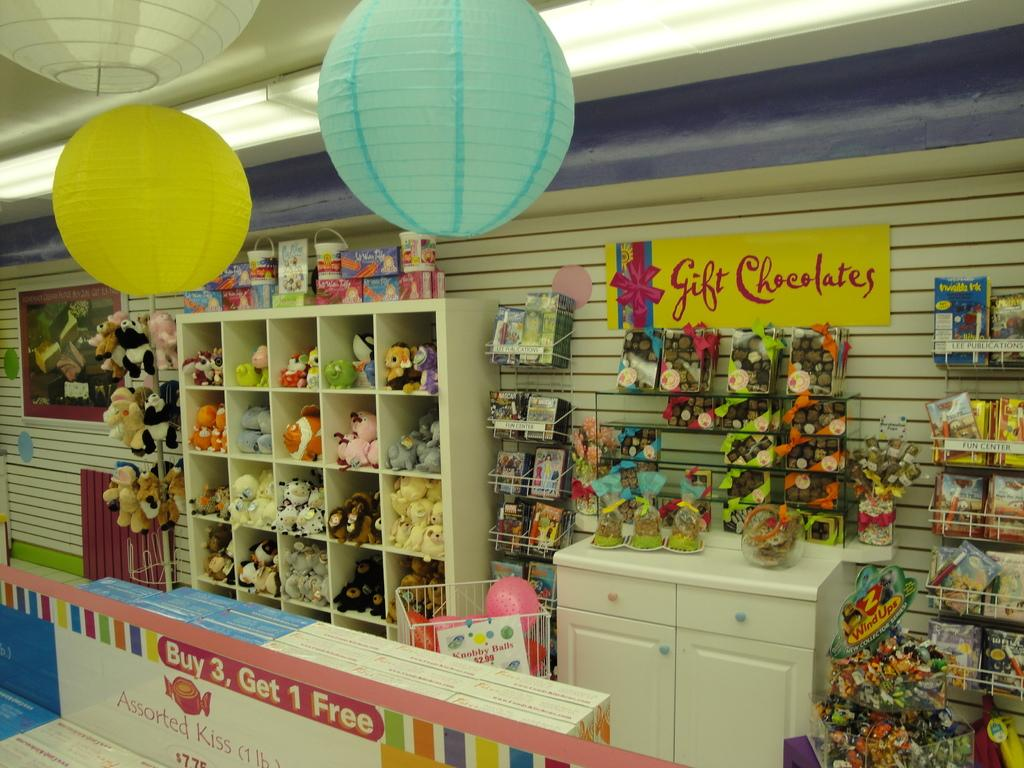<image>
Describe the image concisely. Th einterior of a gift shop full of stuffed toys, gift chocolates and lanterns. 